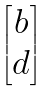<formula> <loc_0><loc_0><loc_500><loc_500>\begin{bmatrix} b \\ d \end{bmatrix}</formula> 